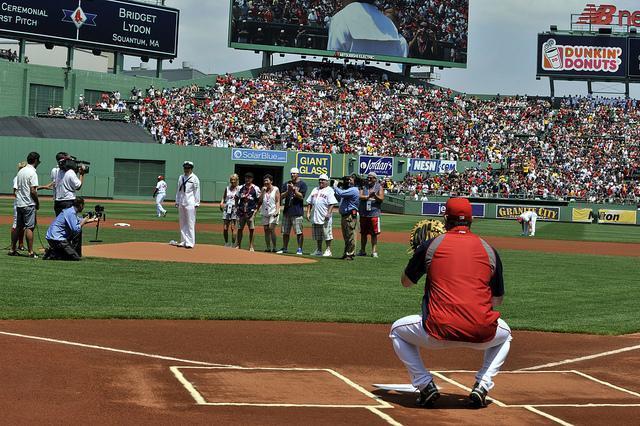What type of pitch is this?
Select the accurate answer and provide explanation: 'Answer: answer
Rationale: rationale.'
Options: Fastball, ceremonial pitch, knuckleball, forkball. Answer: ceremonial pitch.
Rationale: The pitch is for fun. 